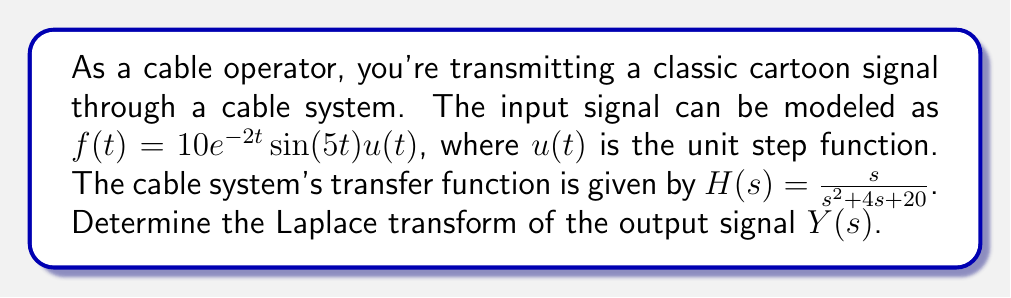Solve this math problem. Let's approach this step-by-step:

1) First, we need to find the Laplace transform of the input signal $f(t)$. The Laplace transform of $e^{at}\sin(bt)u(t)$ is $\frac{b}{(s-a)^2 + b^2}$.

2) For our input signal $f(t) = 10e^{-2t}\sin(5t)u(t)$, we have $a = -2$ and $b = 5$. Let's call the Laplace transform of the input $F(s)$:

   $$F(s) = 10 \cdot \frac{5}{(s+2)^2 + 5^2} = \frac{50}{(s+2)^2 + 25}$$

3) The output $Y(s)$ is the product of the input transform $F(s)$ and the transfer function $H(s)$:

   $$Y(s) = F(s) \cdot H(s) = \frac{50}{(s+2)^2 + 25} \cdot \frac{s}{s^2 + 4s + 20}$$

4) Simplify:

   $$Y(s) = \frac{50s}{((s+2)^2 + 25)(s^2 + 4s + 20)}$$

5) Expand the denominator:

   $$Y(s) = \frac{50s}{(s^2 + 4s + 4 + 25)(s^2 + 4s + 20)}$$
   
   $$Y(s) = \frac{50s}{(s^2 + 4s + 29)(s^2 + 4s + 20)}$$

This is the final form of the Laplace transform of the output signal.
Answer: $$Y(s) = \frac{50s}{(s^2 + 4s + 29)(s^2 + 4s + 20)}$$ 